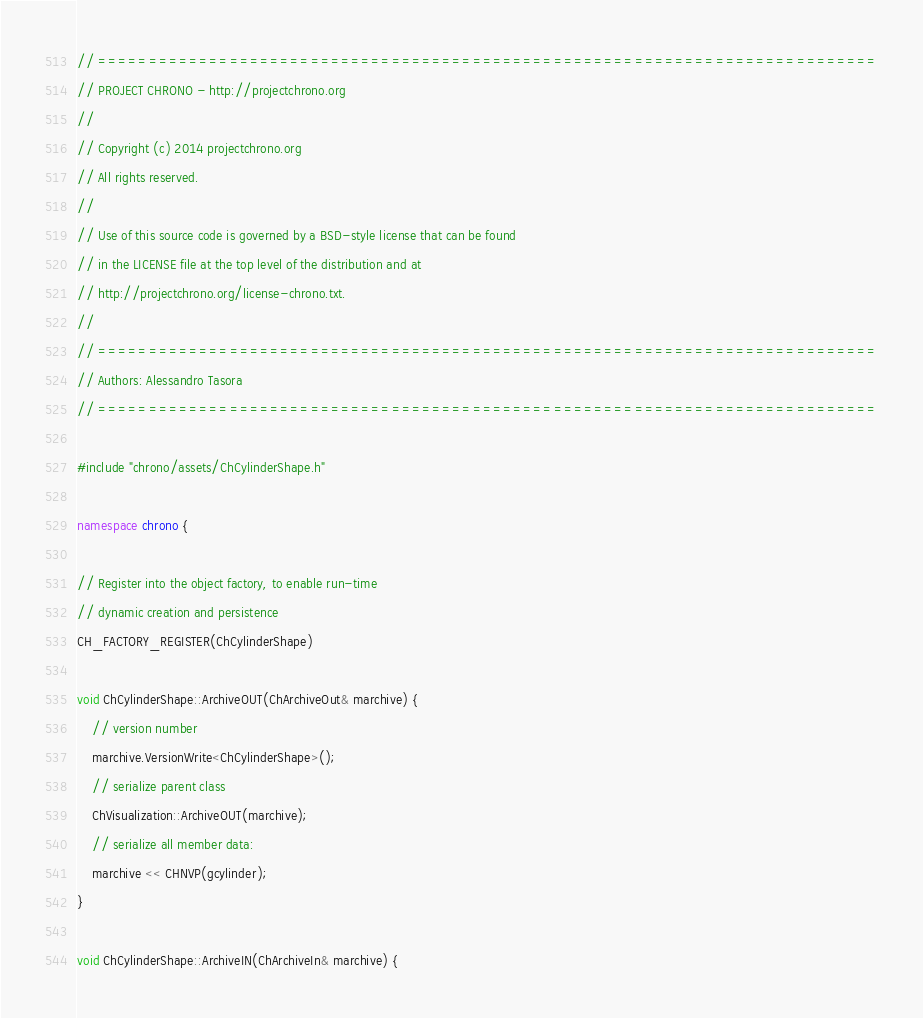Convert code to text. <code><loc_0><loc_0><loc_500><loc_500><_C++_>// =============================================================================
// PROJECT CHRONO - http://projectchrono.org
//
// Copyright (c) 2014 projectchrono.org
// All rights reserved.
//
// Use of this source code is governed by a BSD-style license that can be found
// in the LICENSE file at the top level of the distribution and at
// http://projectchrono.org/license-chrono.txt.
//
// =============================================================================
// Authors: Alessandro Tasora
// =============================================================================

#include "chrono/assets/ChCylinderShape.h"

namespace chrono {

// Register into the object factory, to enable run-time
// dynamic creation and persistence
CH_FACTORY_REGISTER(ChCylinderShape)

void ChCylinderShape::ArchiveOUT(ChArchiveOut& marchive) {
    // version number
    marchive.VersionWrite<ChCylinderShape>();
    // serialize parent class
    ChVisualization::ArchiveOUT(marchive);
    // serialize all member data:
    marchive << CHNVP(gcylinder);
}

void ChCylinderShape::ArchiveIN(ChArchiveIn& marchive) {</code> 